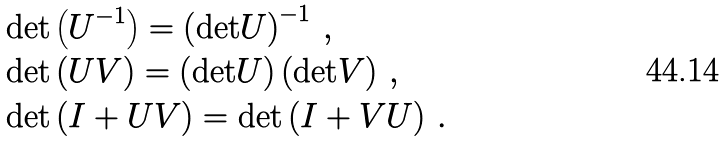<formula> <loc_0><loc_0><loc_500><loc_500>& \text {det} \left ( U ^ { - 1 } \right ) = \left ( \text {det} U \right ) ^ { - 1 } \, , \\ & \text {det} \left ( U V \right ) = \left ( \text {det} U \right ) \left ( \text {det} V \right ) \, , \\ & \text {det} \left ( I + U V \right ) = \text {det} \left ( I + V U \right ) \, .</formula> 